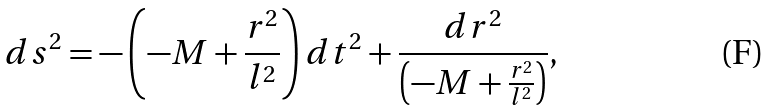<formula> <loc_0><loc_0><loc_500><loc_500>d s ^ { 2 } = - \left ( - M + \frac { r ^ { 2 } } { l ^ { 2 } } \right ) d t ^ { 2 } + \frac { d r ^ { 2 } } { \left ( - M + \frac { r ^ { 2 } } { l ^ { 2 } } \right ) } ,</formula> 